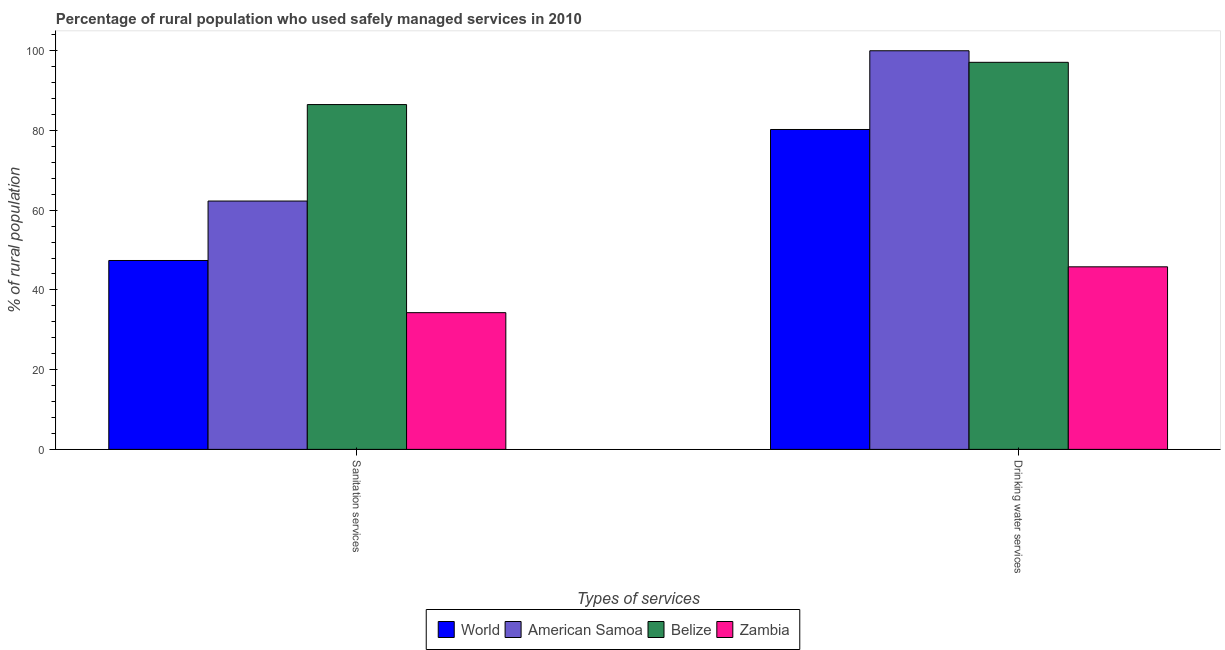Are the number of bars per tick equal to the number of legend labels?
Provide a succinct answer. Yes. How many bars are there on the 2nd tick from the left?
Ensure brevity in your answer.  4. What is the label of the 2nd group of bars from the left?
Provide a succinct answer. Drinking water services. What is the percentage of rural population who used sanitation services in World?
Give a very brief answer. 47.39. Across all countries, what is the maximum percentage of rural population who used drinking water services?
Offer a terse response. 100. Across all countries, what is the minimum percentage of rural population who used sanitation services?
Offer a terse response. 34.3. In which country was the percentage of rural population who used sanitation services maximum?
Your response must be concise. Belize. In which country was the percentage of rural population who used drinking water services minimum?
Your response must be concise. Zambia. What is the total percentage of rural population who used sanitation services in the graph?
Offer a very short reply. 230.49. What is the difference between the percentage of rural population who used drinking water services in American Samoa and the percentage of rural population who used sanitation services in Zambia?
Offer a very short reply. 65.7. What is the average percentage of rural population who used drinking water services per country?
Offer a very short reply. 80.79. What is the difference between the percentage of rural population who used drinking water services and percentage of rural population who used sanitation services in Belize?
Your answer should be compact. 10.6. In how many countries, is the percentage of rural population who used drinking water services greater than 88 %?
Provide a short and direct response. 2. What is the ratio of the percentage of rural population who used drinking water services in Zambia to that in American Samoa?
Give a very brief answer. 0.46. Is the percentage of rural population who used sanitation services in American Samoa less than that in World?
Provide a succinct answer. No. What does the 1st bar from the left in Drinking water services represents?
Give a very brief answer. World. What does the 4th bar from the right in Drinking water services represents?
Provide a short and direct response. World. How many bars are there?
Your answer should be compact. 8. Are all the bars in the graph horizontal?
Your answer should be compact. No. Does the graph contain any zero values?
Ensure brevity in your answer.  No. Where does the legend appear in the graph?
Provide a short and direct response. Bottom center. How many legend labels are there?
Your answer should be very brief. 4. What is the title of the graph?
Provide a succinct answer. Percentage of rural population who used safely managed services in 2010. What is the label or title of the X-axis?
Ensure brevity in your answer.  Types of services. What is the label or title of the Y-axis?
Offer a terse response. % of rural population. What is the % of rural population of World in Sanitation services?
Provide a short and direct response. 47.39. What is the % of rural population in American Samoa in Sanitation services?
Ensure brevity in your answer.  62.3. What is the % of rural population in Belize in Sanitation services?
Make the answer very short. 86.5. What is the % of rural population in Zambia in Sanitation services?
Provide a succinct answer. 34.3. What is the % of rural population of World in Drinking water services?
Ensure brevity in your answer.  80.25. What is the % of rural population of American Samoa in Drinking water services?
Make the answer very short. 100. What is the % of rural population in Belize in Drinking water services?
Your answer should be compact. 97.1. What is the % of rural population of Zambia in Drinking water services?
Keep it short and to the point. 45.8. Across all Types of services, what is the maximum % of rural population of World?
Keep it short and to the point. 80.25. Across all Types of services, what is the maximum % of rural population in Belize?
Provide a succinct answer. 97.1. Across all Types of services, what is the maximum % of rural population in Zambia?
Your answer should be compact. 45.8. Across all Types of services, what is the minimum % of rural population of World?
Make the answer very short. 47.39. Across all Types of services, what is the minimum % of rural population of American Samoa?
Keep it short and to the point. 62.3. Across all Types of services, what is the minimum % of rural population of Belize?
Offer a very short reply. 86.5. Across all Types of services, what is the minimum % of rural population in Zambia?
Ensure brevity in your answer.  34.3. What is the total % of rural population of World in the graph?
Provide a short and direct response. 127.64. What is the total % of rural population of American Samoa in the graph?
Keep it short and to the point. 162.3. What is the total % of rural population in Belize in the graph?
Your answer should be compact. 183.6. What is the total % of rural population in Zambia in the graph?
Give a very brief answer. 80.1. What is the difference between the % of rural population of World in Sanitation services and that in Drinking water services?
Offer a terse response. -32.86. What is the difference between the % of rural population in American Samoa in Sanitation services and that in Drinking water services?
Your response must be concise. -37.7. What is the difference between the % of rural population of Belize in Sanitation services and that in Drinking water services?
Make the answer very short. -10.6. What is the difference between the % of rural population in World in Sanitation services and the % of rural population in American Samoa in Drinking water services?
Your answer should be compact. -52.61. What is the difference between the % of rural population of World in Sanitation services and the % of rural population of Belize in Drinking water services?
Offer a terse response. -49.71. What is the difference between the % of rural population of World in Sanitation services and the % of rural population of Zambia in Drinking water services?
Your answer should be compact. 1.59. What is the difference between the % of rural population of American Samoa in Sanitation services and the % of rural population of Belize in Drinking water services?
Your answer should be compact. -34.8. What is the difference between the % of rural population of Belize in Sanitation services and the % of rural population of Zambia in Drinking water services?
Offer a terse response. 40.7. What is the average % of rural population of World per Types of services?
Give a very brief answer. 63.82. What is the average % of rural population of American Samoa per Types of services?
Provide a succinct answer. 81.15. What is the average % of rural population in Belize per Types of services?
Provide a succinct answer. 91.8. What is the average % of rural population in Zambia per Types of services?
Your response must be concise. 40.05. What is the difference between the % of rural population in World and % of rural population in American Samoa in Sanitation services?
Your answer should be compact. -14.91. What is the difference between the % of rural population of World and % of rural population of Belize in Sanitation services?
Your answer should be very brief. -39.11. What is the difference between the % of rural population of World and % of rural population of Zambia in Sanitation services?
Your response must be concise. 13.09. What is the difference between the % of rural population in American Samoa and % of rural population in Belize in Sanitation services?
Keep it short and to the point. -24.2. What is the difference between the % of rural population of American Samoa and % of rural population of Zambia in Sanitation services?
Make the answer very short. 28. What is the difference between the % of rural population in Belize and % of rural population in Zambia in Sanitation services?
Offer a very short reply. 52.2. What is the difference between the % of rural population of World and % of rural population of American Samoa in Drinking water services?
Give a very brief answer. -19.75. What is the difference between the % of rural population in World and % of rural population in Belize in Drinking water services?
Offer a terse response. -16.85. What is the difference between the % of rural population in World and % of rural population in Zambia in Drinking water services?
Give a very brief answer. 34.45. What is the difference between the % of rural population of American Samoa and % of rural population of Zambia in Drinking water services?
Provide a succinct answer. 54.2. What is the difference between the % of rural population in Belize and % of rural population in Zambia in Drinking water services?
Keep it short and to the point. 51.3. What is the ratio of the % of rural population of World in Sanitation services to that in Drinking water services?
Provide a short and direct response. 0.59. What is the ratio of the % of rural population in American Samoa in Sanitation services to that in Drinking water services?
Provide a succinct answer. 0.62. What is the ratio of the % of rural population of Belize in Sanitation services to that in Drinking water services?
Give a very brief answer. 0.89. What is the ratio of the % of rural population in Zambia in Sanitation services to that in Drinking water services?
Ensure brevity in your answer.  0.75. What is the difference between the highest and the second highest % of rural population in World?
Give a very brief answer. 32.86. What is the difference between the highest and the second highest % of rural population in American Samoa?
Offer a terse response. 37.7. What is the difference between the highest and the second highest % of rural population in Belize?
Your answer should be compact. 10.6. What is the difference between the highest and the second highest % of rural population of Zambia?
Provide a succinct answer. 11.5. What is the difference between the highest and the lowest % of rural population of World?
Keep it short and to the point. 32.86. What is the difference between the highest and the lowest % of rural population of American Samoa?
Give a very brief answer. 37.7. What is the difference between the highest and the lowest % of rural population of Zambia?
Provide a short and direct response. 11.5. 